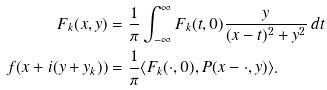Convert formula to latex. <formula><loc_0><loc_0><loc_500><loc_500>F _ { k } ( x , y ) & = \frac { 1 } { \pi } \int _ { - \infty } ^ { \infty } F _ { k } ( t , 0 ) \frac { y } { ( x - t ) ^ { 2 } + y ^ { 2 } } \, d t \\ f ( x + i ( y + y _ { k } ) ) & = \frac { 1 } { \pi } \langle F _ { k } ( \cdot , 0 ) , P ( x - \cdot , y ) \rangle .</formula> 